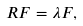Convert formula to latex. <formula><loc_0><loc_0><loc_500><loc_500>R F = \lambda F ,</formula> 